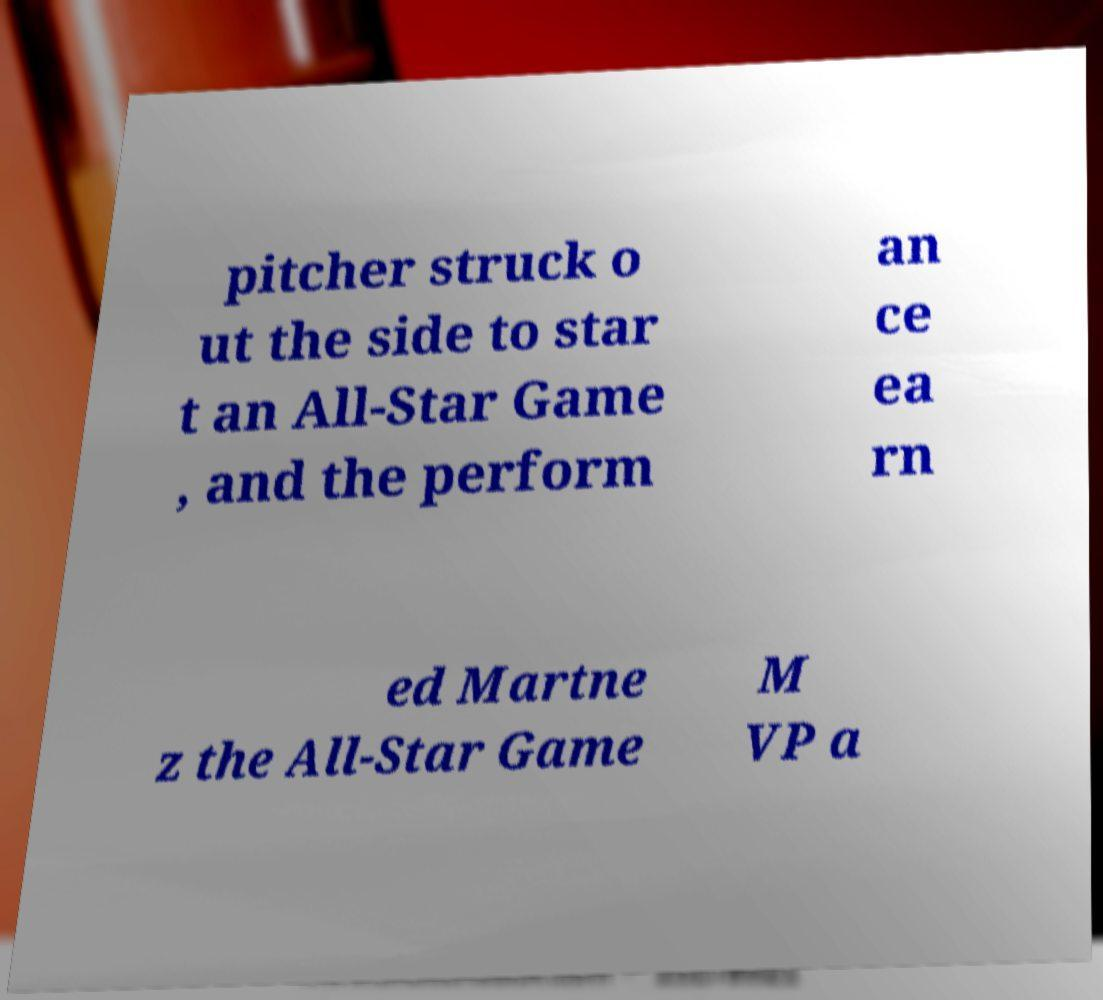Please read and relay the text visible in this image. What does it say? pitcher struck o ut the side to star t an All-Star Game , and the perform an ce ea rn ed Martne z the All-Star Game M VP a 